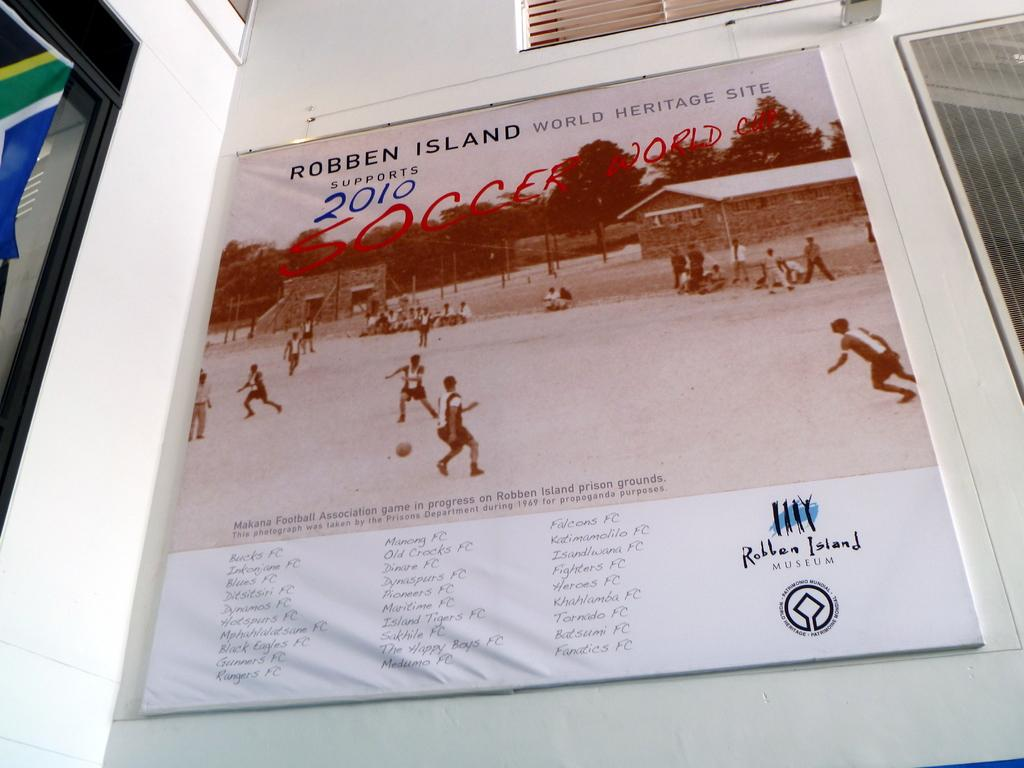<image>
Create a compact narrative representing the image presented. Robben Island world heritage site billboard sign in white 